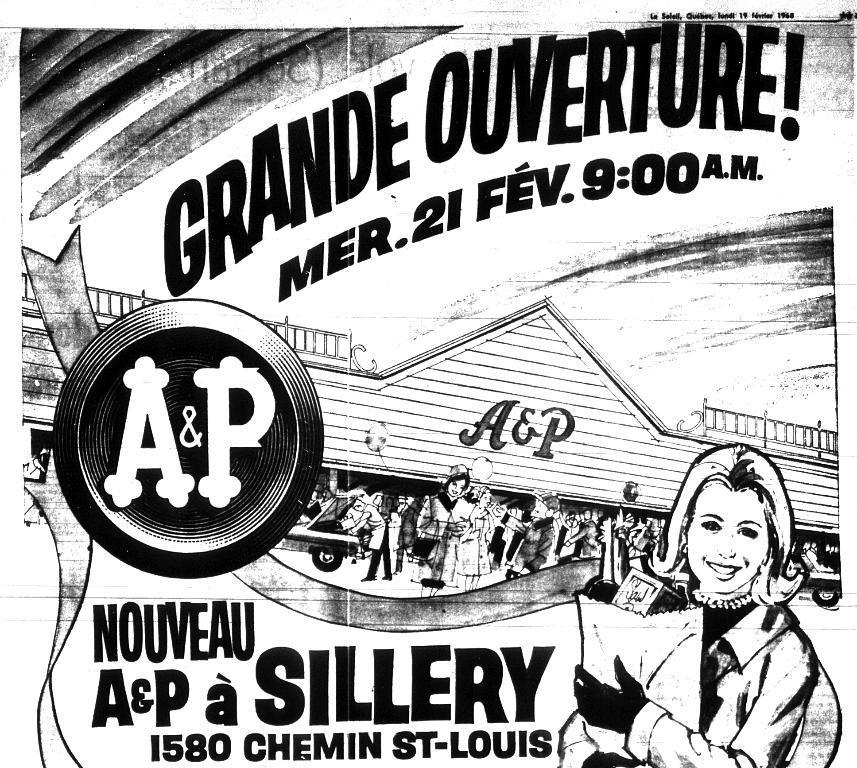How would you summarize this image in a sentence or two? This image consists of a poster with a few images and a text on it. It is a black and white image. 